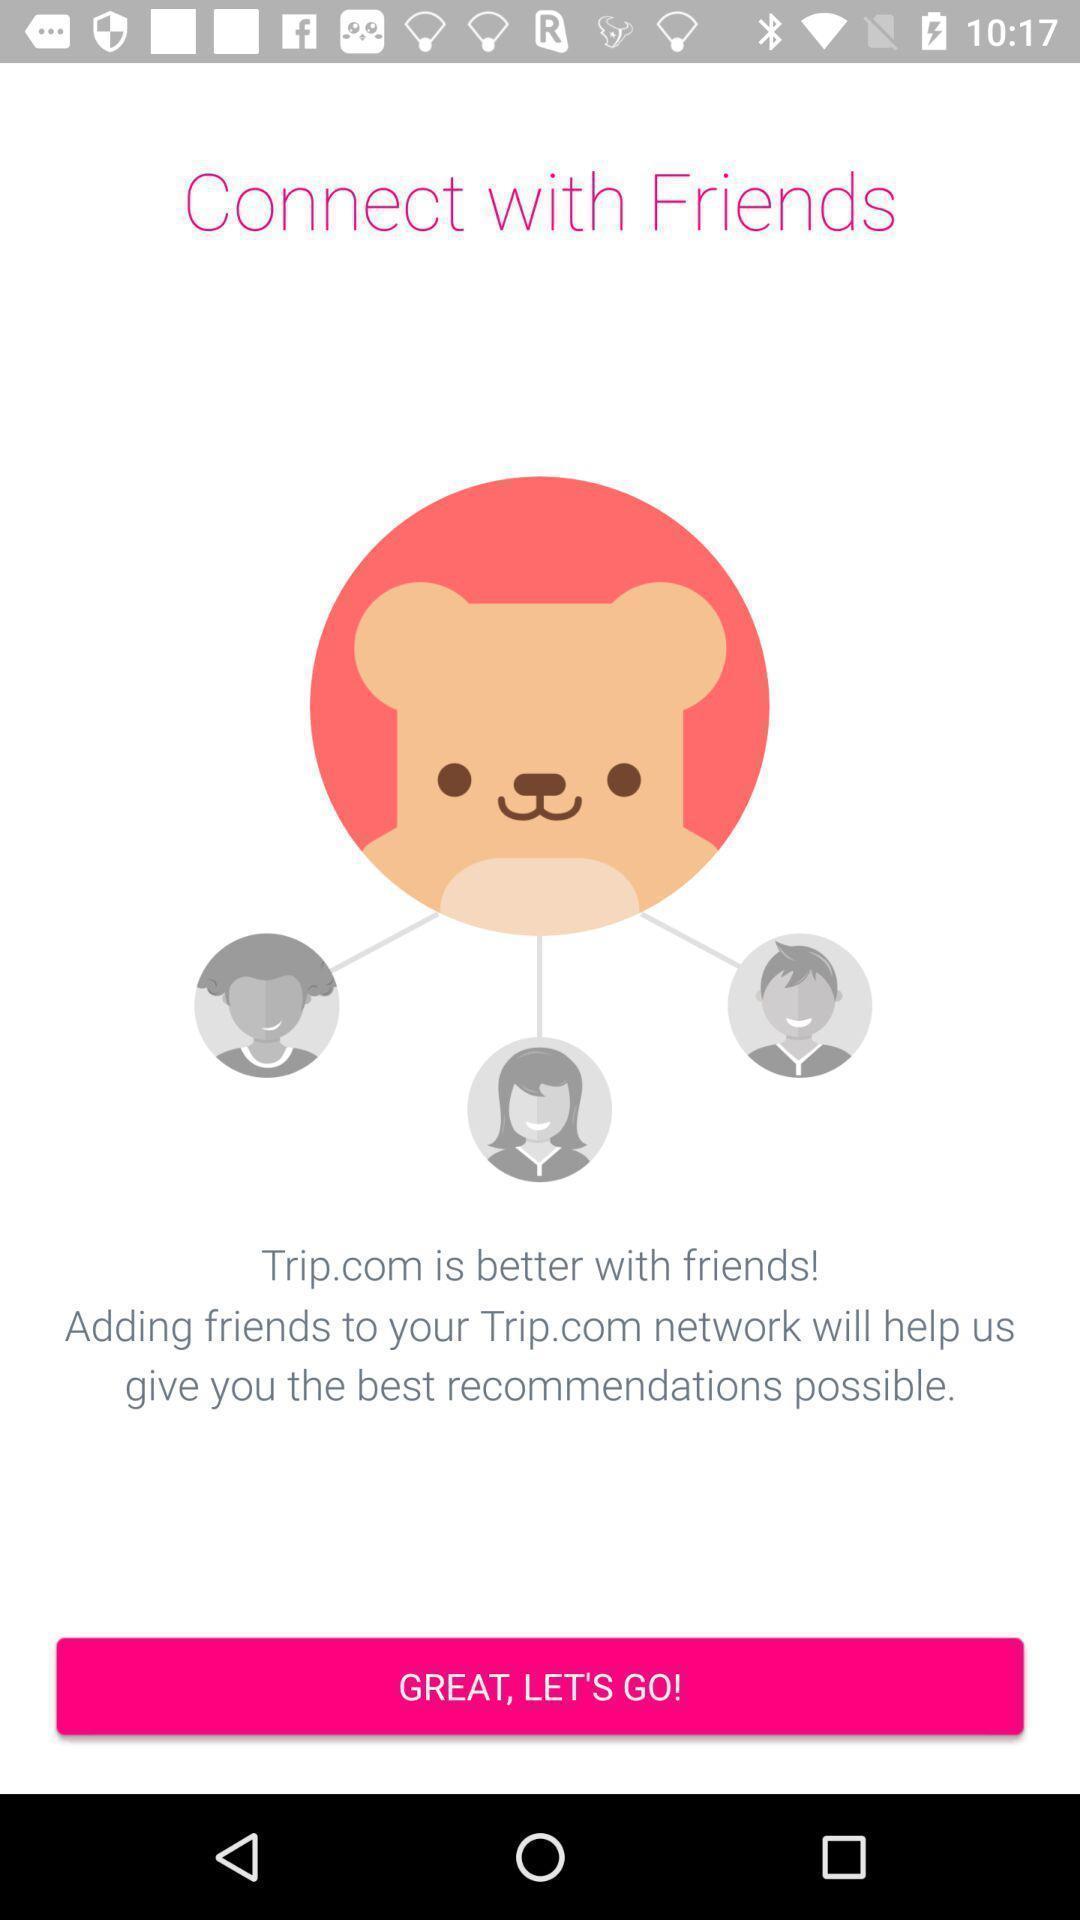Give me a narrative description of this picture. Welcome page for a social app. 